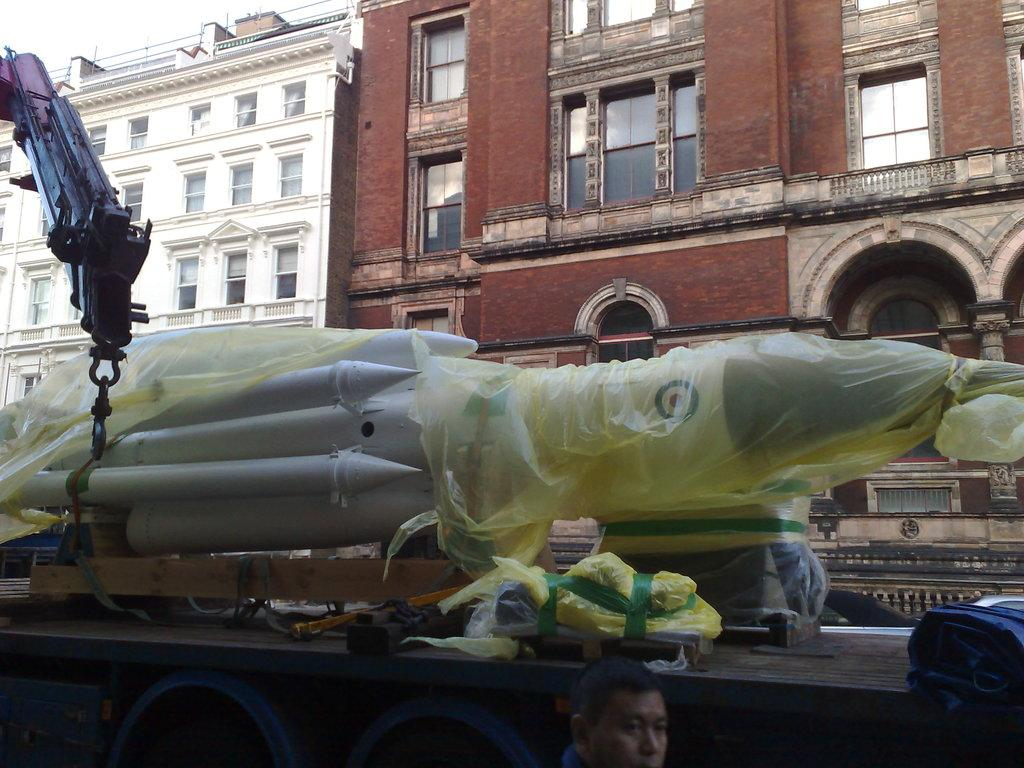What is the main subject of the image? The main subject of the image is a rocket on a vehicle. Can you describe the person visible in the image? There is a person visible in the image, but their specific appearance or actions are not mentioned in the facts. What can be seen in the background of the image? In the background of the image, there are buildings with windows and the sky is visible. What type of toothpaste is being used to clean the rocket in the image? There is no toothpaste present in the image, and the rocket is not being cleaned. 